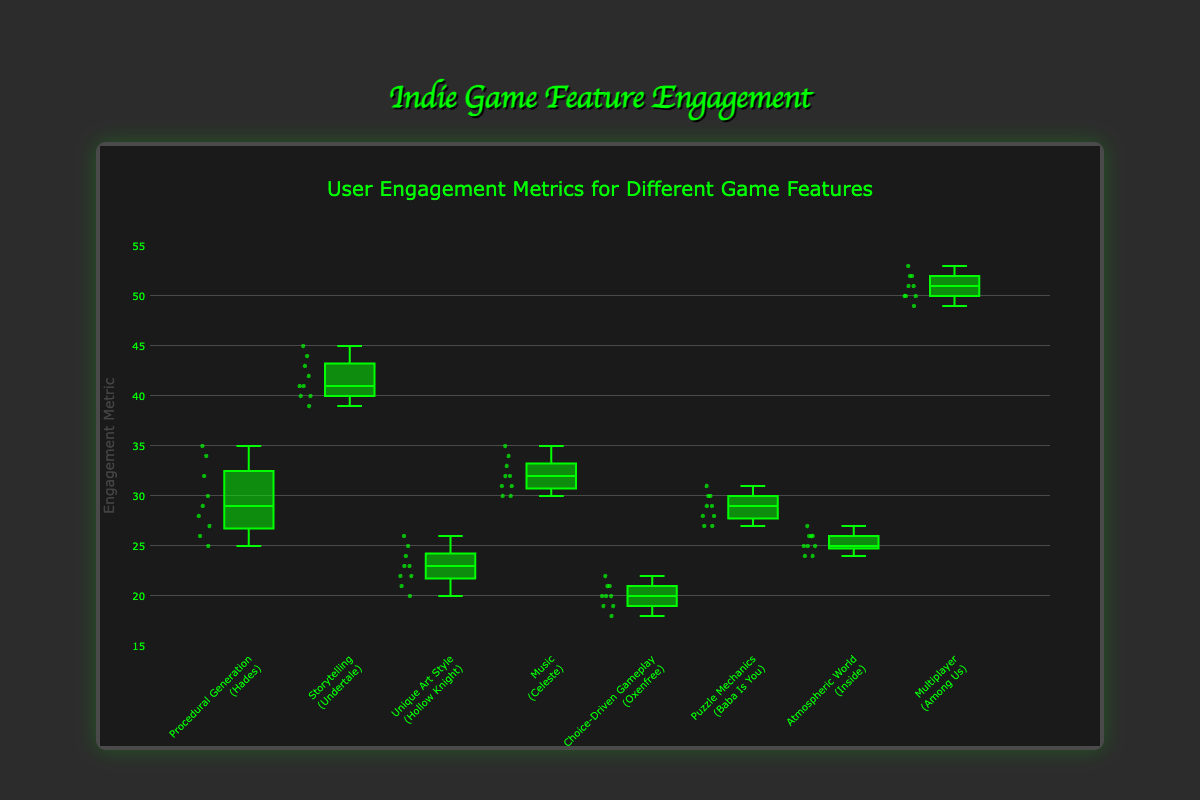What is the median engagement metric for the "Storytelling" feature? To find the median, we need to organize the engagement metrics for "Storytelling" and find the middle value. The metrics are [39, 40, 40, 41, 41, 42, 43, 44, 45]. The median value is the middle one, which is 41.
Answer: 41 Which game has the highest range of engagement metrics? The range of engagement metrics is determined by the difference between the maximum and minimum values for each feature. For "Among Us", the maximum is 53 and the minimum is 49, giving a range of 4. For others: "Hades" (35-25=10), "Undertale" (45-39=6), "Hollow Knight" (26-20=6), "Celeste" (35-30=5), "Oxenfree" (22-18=4), "Baba Is You" (31-27=4), "Inside" (27-24=3). Therefore, "Hades" has the highest range.
Answer: Hades What feature has the lowest median engagement? Locate the median values of all features in the box plots. For "Procedural Generation" (Hades), it's around 28; "Storytelling" (Undertale) is 41; "Unique Art Style" (Hollow Knight) is 23; "Music" (Celeste) is 32; "Choice-Driven Gameplay" (Oxenfree) is 20; "Puzzle Mechanics" (Baba Is You) is 29; "Atmospheric World" (Inside) is 25; "Multiplayer" (Among Us) is 51. "Choice-Driven Gameplay" has the lowest median.
Answer: Choice-Driven Gameplay Which feature has the smallest interquartile range (IQR)? IQR is the difference between the 75th and 25th percentiles. By inspecting the box plots, "Atmospheric World" (Inside) has the smallest IQR because its box (which represents the IQR) appears smallest compared to the others.
Answer: Atmospheric World Are there any outliers in the engagement metrics for "Unique Art Style"? By examining the box plot of "Unique Art Style" (Hollow Knight), we see that all data points lie within the whiskers, indicating no outliers.
Answer: No Is the median engagement for "Procedural Generation" higher than that for "Puzzle Mechanics"? The median value for "Procedural Generation" (Hades) appears slightly above 28, while for "Puzzle Mechanics" (Baba Is You), it is exactly 29. So, the median for "Puzzle Mechanics" is higher.
Answer: No How is the spread of engagement metrics for "Multiplayer" compared to "Music"? The spread of data can be inferred by the length of the box and whiskers. "Multiplayer" (Among Us) has a consistently high spread, with the box and whiskers stretching from 49 to 53. For "Music" (Celeste), the data is also spread but not as wide, from 30 to 35. Thus, "Multiplayer" has a slightly higher spread.
Answer: Wider What is the first quartile (Q1) of the engagement metrics for "Atmospheric World"? Q1 is the 25th percentile. For "Atmospheric World" (Inside), by looking at the lower boundary of the box plot, Q1 is around 24.
Answer: 24 